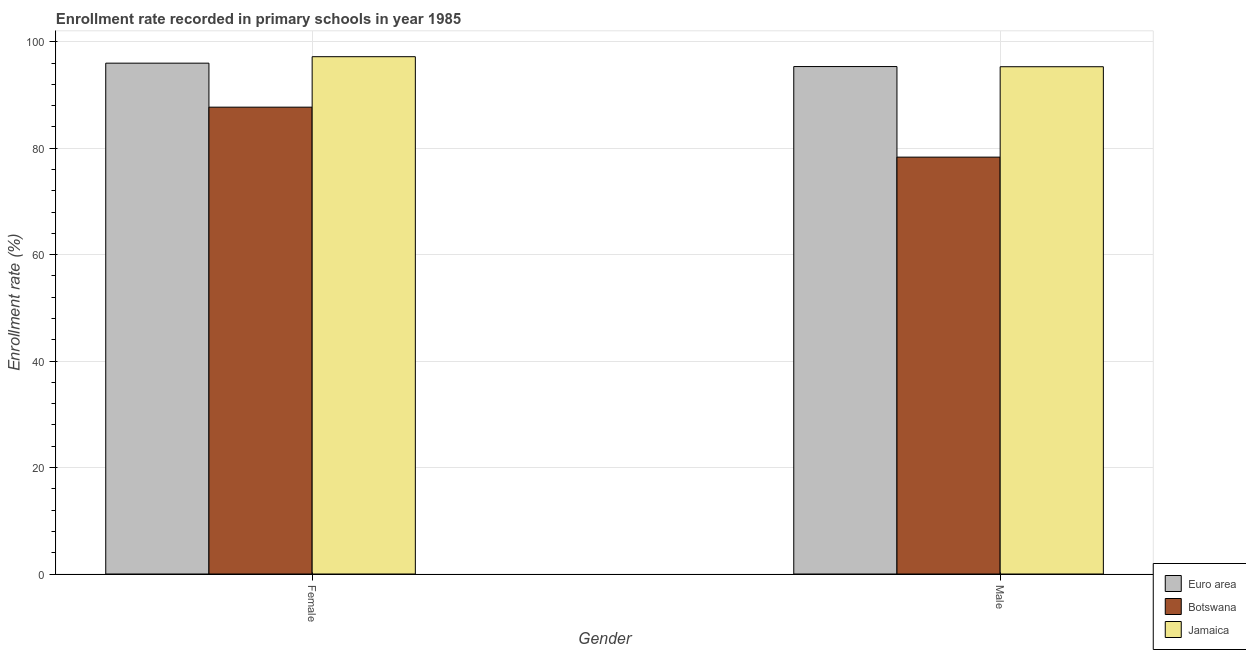How many different coloured bars are there?
Offer a very short reply. 3. How many groups of bars are there?
Provide a succinct answer. 2. How many bars are there on the 2nd tick from the left?
Keep it short and to the point. 3. How many bars are there on the 1st tick from the right?
Make the answer very short. 3. What is the enrollment rate of female students in Botswana?
Your response must be concise. 87.72. Across all countries, what is the maximum enrollment rate of female students?
Your response must be concise. 97.21. Across all countries, what is the minimum enrollment rate of female students?
Your answer should be compact. 87.72. In which country was the enrollment rate of male students maximum?
Make the answer very short. Euro area. In which country was the enrollment rate of male students minimum?
Your answer should be very brief. Botswana. What is the total enrollment rate of male students in the graph?
Make the answer very short. 269.01. What is the difference between the enrollment rate of male students in Botswana and that in Euro area?
Your answer should be very brief. -17.02. What is the difference between the enrollment rate of male students in Jamaica and the enrollment rate of female students in Euro area?
Your response must be concise. -0.67. What is the average enrollment rate of male students per country?
Give a very brief answer. 89.67. What is the difference between the enrollment rate of male students and enrollment rate of female students in Botswana?
Offer a very short reply. -9.39. In how many countries, is the enrollment rate of male students greater than 96 %?
Make the answer very short. 0. What is the ratio of the enrollment rate of male students in Euro area to that in Botswana?
Your answer should be very brief. 1.22. What does the 1st bar from the left in Male represents?
Provide a succinct answer. Euro area. What does the 3rd bar from the right in Female represents?
Your answer should be compact. Euro area. How many bars are there?
Give a very brief answer. 6. How many countries are there in the graph?
Offer a terse response. 3. Are the values on the major ticks of Y-axis written in scientific E-notation?
Offer a terse response. No. Does the graph contain grids?
Keep it short and to the point. Yes. Where does the legend appear in the graph?
Offer a very short reply. Bottom right. How many legend labels are there?
Give a very brief answer. 3. How are the legend labels stacked?
Offer a very short reply. Vertical. What is the title of the graph?
Make the answer very short. Enrollment rate recorded in primary schools in year 1985. Does "Zambia" appear as one of the legend labels in the graph?
Give a very brief answer. No. What is the label or title of the Y-axis?
Give a very brief answer. Enrollment rate (%). What is the Enrollment rate (%) of Euro area in Female?
Your response must be concise. 95.99. What is the Enrollment rate (%) in Botswana in Female?
Make the answer very short. 87.72. What is the Enrollment rate (%) in Jamaica in Female?
Make the answer very short. 97.21. What is the Enrollment rate (%) in Euro area in Male?
Your response must be concise. 95.35. What is the Enrollment rate (%) of Botswana in Male?
Offer a terse response. 78.33. What is the Enrollment rate (%) of Jamaica in Male?
Offer a terse response. 95.32. Across all Gender, what is the maximum Enrollment rate (%) of Euro area?
Provide a short and direct response. 95.99. Across all Gender, what is the maximum Enrollment rate (%) in Botswana?
Provide a succinct answer. 87.72. Across all Gender, what is the maximum Enrollment rate (%) in Jamaica?
Your answer should be very brief. 97.21. Across all Gender, what is the minimum Enrollment rate (%) in Euro area?
Offer a terse response. 95.35. Across all Gender, what is the minimum Enrollment rate (%) of Botswana?
Give a very brief answer. 78.33. Across all Gender, what is the minimum Enrollment rate (%) in Jamaica?
Your response must be concise. 95.32. What is the total Enrollment rate (%) in Euro area in the graph?
Give a very brief answer. 191.34. What is the total Enrollment rate (%) of Botswana in the graph?
Your response must be concise. 166.06. What is the total Enrollment rate (%) of Jamaica in the graph?
Provide a succinct answer. 192.53. What is the difference between the Enrollment rate (%) in Euro area in Female and that in Male?
Offer a terse response. 0.64. What is the difference between the Enrollment rate (%) in Botswana in Female and that in Male?
Ensure brevity in your answer.  9.39. What is the difference between the Enrollment rate (%) of Jamaica in Female and that in Male?
Make the answer very short. 1.89. What is the difference between the Enrollment rate (%) of Euro area in Female and the Enrollment rate (%) of Botswana in Male?
Make the answer very short. 17.66. What is the difference between the Enrollment rate (%) of Euro area in Female and the Enrollment rate (%) of Jamaica in Male?
Make the answer very short. 0.67. What is the difference between the Enrollment rate (%) of Botswana in Female and the Enrollment rate (%) of Jamaica in Male?
Keep it short and to the point. -7.6. What is the average Enrollment rate (%) in Euro area per Gender?
Your answer should be compact. 95.67. What is the average Enrollment rate (%) in Botswana per Gender?
Make the answer very short. 83.03. What is the average Enrollment rate (%) of Jamaica per Gender?
Give a very brief answer. 96.26. What is the difference between the Enrollment rate (%) in Euro area and Enrollment rate (%) in Botswana in Female?
Provide a short and direct response. 8.27. What is the difference between the Enrollment rate (%) in Euro area and Enrollment rate (%) in Jamaica in Female?
Provide a succinct answer. -1.22. What is the difference between the Enrollment rate (%) in Botswana and Enrollment rate (%) in Jamaica in Female?
Provide a short and direct response. -9.48. What is the difference between the Enrollment rate (%) of Euro area and Enrollment rate (%) of Botswana in Male?
Provide a succinct answer. 17.02. What is the difference between the Enrollment rate (%) in Euro area and Enrollment rate (%) in Jamaica in Male?
Your answer should be compact. 0.03. What is the difference between the Enrollment rate (%) of Botswana and Enrollment rate (%) of Jamaica in Male?
Your answer should be compact. -16.99. What is the ratio of the Enrollment rate (%) in Botswana in Female to that in Male?
Your answer should be compact. 1.12. What is the ratio of the Enrollment rate (%) of Jamaica in Female to that in Male?
Offer a very short reply. 1.02. What is the difference between the highest and the second highest Enrollment rate (%) of Euro area?
Provide a short and direct response. 0.64. What is the difference between the highest and the second highest Enrollment rate (%) in Botswana?
Your answer should be very brief. 9.39. What is the difference between the highest and the second highest Enrollment rate (%) of Jamaica?
Give a very brief answer. 1.89. What is the difference between the highest and the lowest Enrollment rate (%) of Euro area?
Your response must be concise. 0.64. What is the difference between the highest and the lowest Enrollment rate (%) of Botswana?
Give a very brief answer. 9.39. What is the difference between the highest and the lowest Enrollment rate (%) of Jamaica?
Make the answer very short. 1.89. 